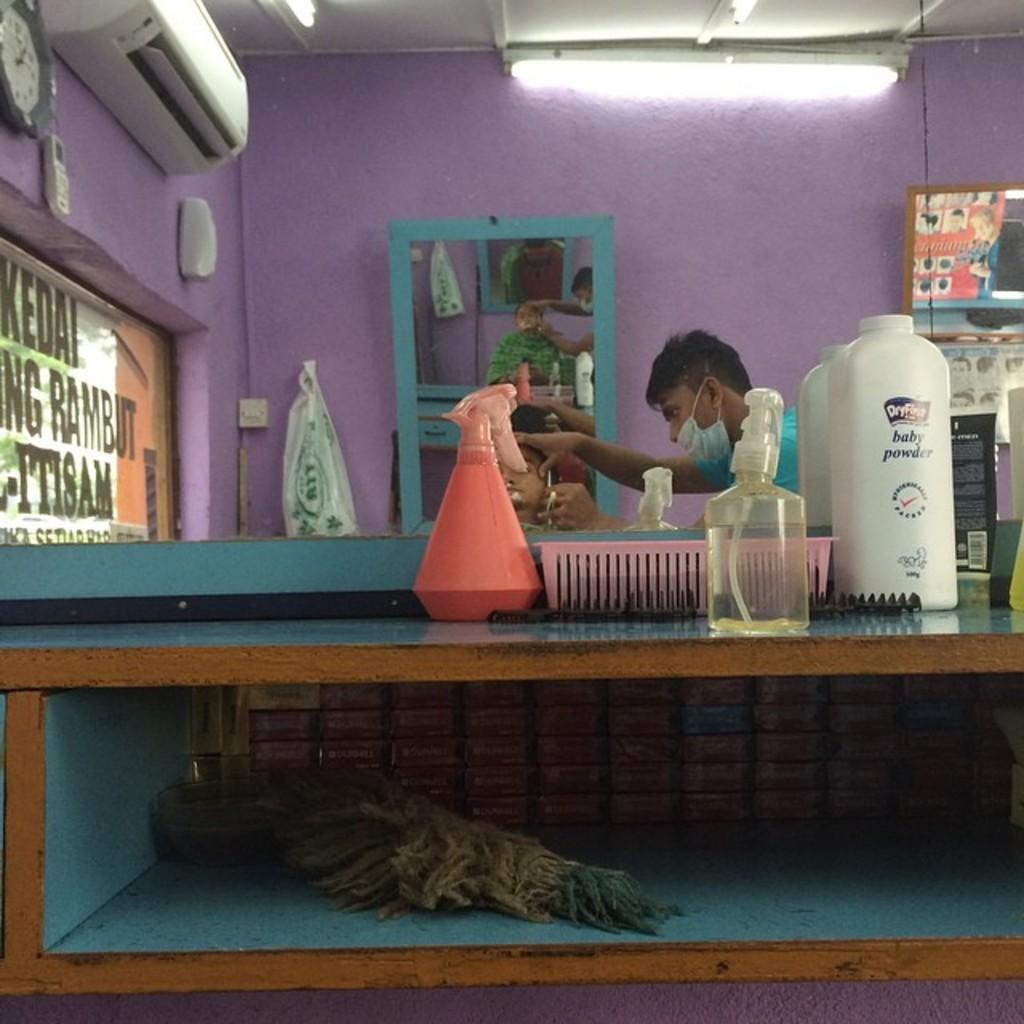<image>
Summarize the visual content of the image. bottle of dryfirst baby powder, combs, and spray bottle on counter of barber shop as someone gives a shave 